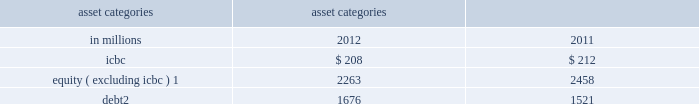Management 2019s discussion and analysis sensitivity measures certain portfolios and individual positions are not included in var because var is not the most appropriate risk measure .
The market risk of these positions is determined by estimating the potential reduction in net revenues of a 10% ( 10 % ) decline in the underlying asset value .
The table below presents market risk for positions that are not included in var .
These measures do not reflect diversification benefits across asset categories and therefore have not been aggregated .
Asset categories 10% ( 10 % ) sensitivity amount as of december in millions 2012 2011 .
Equity ( excluding icbc ) 1 2263 2458 debt 2 1676 1521 1 .
Relates to private and restricted public equity securities , including interests in firm-sponsored funds that invest in corporate equities and real estate and interests in firm-sponsored hedge funds .
Primarily relates to interests in our firm-sponsored funds that invest in corporate mezzanine and senior debt instruments .
Also includes loans backed by commercial and residential real estate , corporate bank loans and other corporate debt , including acquired portfolios of distressed loans .
Var excludes the impact of changes in counterparty and our own credit spreads on derivatives as well as changes in our own credit spreads on unsecured borrowings for which the fair value option was elected .
The estimated sensitivity to a one basis point increase in credit spreads ( counterparty and our own ) on derivatives was a $ 3 million gain ( including hedges ) as of december 2012 .
In addition , the estimated sensitivity to a one basis point increase in our own credit spreads on unsecured borrowings for which the fair value option was elected was a $ 7 million gain ( including hedges ) as of december 2012 .
However , the actual net impact of a change in our own credit spreads is also affected by the liquidity , duration and convexity ( as the sensitivity is not linear to changes in yields ) of those unsecured borrowings for which the fair value option was elected , as well as the relative performance of any hedges undertaken .
The firm engages in insurance activities where we reinsure and purchase portfolios of insurance risk and pension liabilities .
The risks associated with these activities include , but are not limited to : equity price , interest rate , reinvestment and mortality risk .
The firm mitigates risks associated with insurance activities through the use of reinsurance and hedging .
Certain of the assets associated with the firm 2019s insurance activities are included in var .
In addition to the positions included in var , we held $ 9.07 billion of securities accounted for as available-for- sale as of december 2012 , which support the firm 2019s reinsurance business .
As of december 2012 , our available- for-sale securities primarily consisted of $ 3.63 billion of corporate debt securities with an average yield of 4% ( 4 % ) , the majority of which will mature after five years , $ 3.38 billion of mortgage and other asset-backed loans and securities with an average yield of 6% ( 6 % ) , the majority of which will mature after ten years , and $ 856 million of u.s .
Government and federal agency obligations with an average yield of 3% ( 3 % ) , the majority of which will mature after five years .
As of december 2012 , such assets were classified as held for sale and were included in 201cother assets . 201d see note 12 to the consolidated financial statements for further information about assets held for sale .
As of december 2011 , we held $ 4.86 billion of securities accounted for as available-for-sale , primarily consisting of $ 1.81 billion of corporate debt securities with an average yield of 5% ( 5 % ) , the majority of which will mature after five years , $ 1.42 billion of mortgage and other asset-backed loans and securities with an average yield of 10% ( 10 % ) , the majority of which will mature after ten years , and $ 662 million of u.s .
Government and federal agency obligations with an average yield of 3% ( 3 % ) , the majority of which will mature after ten years .
In addition , as of december 2012 and december 2011 , we had commitments and held loans for which we have obtained credit loss protection from sumitomo mitsui financial group , inc .
See note 18 to the consolidated financial statements for further information about such lending commitments .
As of december 2012 , the firm also had $ 6.50 billion of loans held for investment which were accounted for at amortized cost and included in 201creceivables from customers and counterparties , 201d substantially all of which had floating interest rates .
The estimated sensitivity to a 100 basis point increase in interest rates on such loans was $ 62 million of additional interest income over a 12-month period , which does not take into account the potential impact of an increase in costs to fund such loans .
See note 8 to the consolidated financial statements for further information about loans held for investment .
Additionally , we make investments accounted for under the equity method and we also make direct investments in real estate , both of which are included in 201cother assets 201d in the consolidated statements of financial condition .
Direct investments in real estate are accounted for at cost less accumulated depreciation .
See note 12 to the consolidated financial statements for information on 201cother assets . 201d goldman sachs 2012 annual report 93 .
As of december 2011 , what percentage of available- for-sale securities was comprised of mortgage and other asset-backed loans and securities? 
Computations: (1.42 / ((1.81 + 1.42) + (662 / 1000)))
Answer: 0.36485. Management 2019s discussion and analysis sensitivity measures certain portfolios and individual positions are not included in var because var is not the most appropriate risk measure .
The market risk of these positions is determined by estimating the potential reduction in net revenues of a 10% ( 10 % ) decline in the underlying asset value .
The table below presents market risk for positions that are not included in var .
These measures do not reflect diversification benefits across asset categories and therefore have not been aggregated .
Asset categories 10% ( 10 % ) sensitivity amount as of december in millions 2012 2011 .
Equity ( excluding icbc ) 1 2263 2458 debt 2 1676 1521 1 .
Relates to private and restricted public equity securities , including interests in firm-sponsored funds that invest in corporate equities and real estate and interests in firm-sponsored hedge funds .
Primarily relates to interests in our firm-sponsored funds that invest in corporate mezzanine and senior debt instruments .
Also includes loans backed by commercial and residential real estate , corporate bank loans and other corporate debt , including acquired portfolios of distressed loans .
Var excludes the impact of changes in counterparty and our own credit spreads on derivatives as well as changes in our own credit spreads on unsecured borrowings for which the fair value option was elected .
The estimated sensitivity to a one basis point increase in credit spreads ( counterparty and our own ) on derivatives was a $ 3 million gain ( including hedges ) as of december 2012 .
In addition , the estimated sensitivity to a one basis point increase in our own credit spreads on unsecured borrowings for which the fair value option was elected was a $ 7 million gain ( including hedges ) as of december 2012 .
However , the actual net impact of a change in our own credit spreads is also affected by the liquidity , duration and convexity ( as the sensitivity is not linear to changes in yields ) of those unsecured borrowings for which the fair value option was elected , as well as the relative performance of any hedges undertaken .
The firm engages in insurance activities where we reinsure and purchase portfolios of insurance risk and pension liabilities .
The risks associated with these activities include , but are not limited to : equity price , interest rate , reinvestment and mortality risk .
The firm mitigates risks associated with insurance activities through the use of reinsurance and hedging .
Certain of the assets associated with the firm 2019s insurance activities are included in var .
In addition to the positions included in var , we held $ 9.07 billion of securities accounted for as available-for- sale as of december 2012 , which support the firm 2019s reinsurance business .
As of december 2012 , our available- for-sale securities primarily consisted of $ 3.63 billion of corporate debt securities with an average yield of 4% ( 4 % ) , the majority of which will mature after five years , $ 3.38 billion of mortgage and other asset-backed loans and securities with an average yield of 6% ( 6 % ) , the majority of which will mature after ten years , and $ 856 million of u.s .
Government and federal agency obligations with an average yield of 3% ( 3 % ) , the majority of which will mature after five years .
As of december 2012 , such assets were classified as held for sale and were included in 201cother assets . 201d see note 12 to the consolidated financial statements for further information about assets held for sale .
As of december 2011 , we held $ 4.86 billion of securities accounted for as available-for-sale , primarily consisting of $ 1.81 billion of corporate debt securities with an average yield of 5% ( 5 % ) , the majority of which will mature after five years , $ 1.42 billion of mortgage and other asset-backed loans and securities with an average yield of 10% ( 10 % ) , the majority of which will mature after ten years , and $ 662 million of u.s .
Government and federal agency obligations with an average yield of 3% ( 3 % ) , the majority of which will mature after ten years .
In addition , as of december 2012 and december 2011 , we had commitments and held loans for which we have obtained credit loss protection from sumitomo mitsui financial group , inc .
See note 18 to the consolidated financial statements for further information about such lending commitments .
As of december 2012 , the firm also had $ 6.50 billion of loans held for investment which were accounted for at amortized cost and included in 201creceivables from customers and counterparties , 201d substantially all of which had floating interest rates .
The estimated sensitivity to a 100 basis point increase in interest rates on such loans was $ 62 million of additional interest income over a 12-month period , which does not take into account the potential impact of an increase in costs to fund such loans .
See note 8 to the consolidated financial statements for further information about loans held for investment .
Additionally , we make investments accounted for under the equity method and we also make direct investments in real estate , both of which are included in 201cother assets 201d in the consolidated statements of financial condition .
Direct investments in real estate are accounted for at cost less accumulated depreciation .
See note 12 to the consolidated financial statements for information on 201cother assets . 201d goldman sachs 2012 annual report 93 .
For asset categories 10% ( 10 % ) sensitivity amounts in millions for 2012 2011\\nwhat was the minimum icbc amount? 
Computations: table_min(icbc, none)
Answer: 208.0. Management 2019s discussion and analysis sensitivity measures certain portfolios and individual positions are not included in var because var is not the most appropriate risk measure .
The market risk of these positions is determined by estimating the potential reduction in net revenues of a 10% ( 10 % ) decline in the underlying asset value .
The table below presents market risk for positions that are not included in var .
These measures do not reflect diversification benefits across asset categories and therefore have not been aggregated .
Asset categories 10% ( 10 % ) sensitivity amount as of december in millions 2012 2011 .
Equity ( excluding icbc ) 1 2263 2458 debt 2 1676 1521 1 .
Relates to private and restricted public equity securities , including interests in firm-sponsored funds that invest in corporate equities and real estate and interests in firm-sponsored hedge funds .
Primarily relates to interests in our firm-sponsored funds that invest in corporate mezzanine and senior debt instruments .
Also includes loans backed by commercial and residential real estate , corporate bank loans and other corporate debt , including acquired portfolios of distressed loans .
Var excludes the impact of changes in counterparty and our own credit spreads on derivatives as well as changes in our own credit spreads on unsecured borrowings for which the fair value option was elected .
The estimated sensitivity to a one basis point increase in credit spreads ( counterparty and our own ) on derivatives was a $ 3 million gain ( including hedges ) as of december 2012 .
In addition , the estimated sensitivity to a one basis point increase in our own credit spreads on unsecured borrowings for which the fair value option was elected was a $ 7 million gain ( including hedges ) as of december 2012 .
However , the actual net impact of a change in our own credit spreads is also affected by the liquidity , duration and convexity ( as the sensitivity is not linear to changes in yields ) of those unsecured borrowings for which the fair value option was elected , as well as the relative performance of any hedges undertaken .
The firm engages in insurance activities where we reinsure and purchase portfolios of insurance risk and pension liabilities .
The risks associated with these activities include , but are not limited to : equity price , interest rate , reinvestment and mortality risk .
The firm mitigates risks associated with insurance activities through the use of reinsurance and hedging .
Certain of the assets associated with the firm 2019s insurance activities are included in var .
In addition to the positions included in var , we held $ 9.07 billion of securities accounted for as available-for- sale as of december 2012 , which support the firm 2019s reinsurance business .
As of december 2012 , our available- for-sale securities primarily consisted of $ 3.63 billion of corporate debt securities with an average yield of 4% ( 4 % ) , the majority of which will mature after five years , $ 3.38 billion of mortgage and other asset-backed loans and securities with an average yield of 6% ( 6 % ) , the majority of which will mature after ten years , and $ 856 million of u.s .
Government and federal agency obligations with an average yield of 3% ( 3 % ) , the majority of which will mature after five years .
As of december 2012 , such assets were classified as held for sale and were included in 201cother assets . 201d see note 12 to the consolidated financial statements for further information about assets held for sale .
As of december 2011 , we held $ 4.86 billion of securities accounted for as available-for-sale , primarily consisting of $ 1.81 billion of corporate debt securities with an average yield of 5% ( 5 % ) , the majority of which will mature after five years , $ 1.42 billion of mortgage and other asset-backed loans and securities with an average yield of 10% ( 10 % ) , the majority of which will mature after ten years , and $ 662 million of u.s .
Government and federal agency obligations with an average yield of 3% ( 3 % ) , the majority of which will mature after ten years .
In addition , as of december 2012 and december 2011 , we had commitments and held loans for which we have obtained credit loss protection from sumitomo mitsui financial group , inc .
See note 18 to the consolidated financial statements for further information about such lending commitments .
As of december 2012 , the firm also had $ 6.50 billion of loans held for investment which were accounted for at amortized cost and included in 201creceivables from customers and counterparties , 201d substantially all of which had floating interest rates .
The estimated sensitivity to a 100 basis point increase in interest rates on such loans was $ 62 million of additional interest income over a 12-month period , which does not take into account the potential impact of an increase in costs to fund such loans .
See note 8 to the consolidated financial statements for further information about loans held for investment .
Additionally , we make investments accounted for under the equity method and we also make direct investments in real estate , both of which are included in 201cother assets 201d in the consolidated statements of financial condition .
Direct investments in real estate are accounted for at cost less accumulated depreciation .
See note 12 to the consolidated financial statements for information on 201cother assets . 201d goldman sachs 2012 annual report 93 .
Was the estimated sensitivity to a one basis point increase in credit spreads ( counterparty and our own ) on derivatives greater than the estimated sensitivity to a one basis point increase in our own credit spreads on unsecured borrowings for which the fair value option was elected as of december 2012? 
Computations: (3 > 7)
Answer: no. 